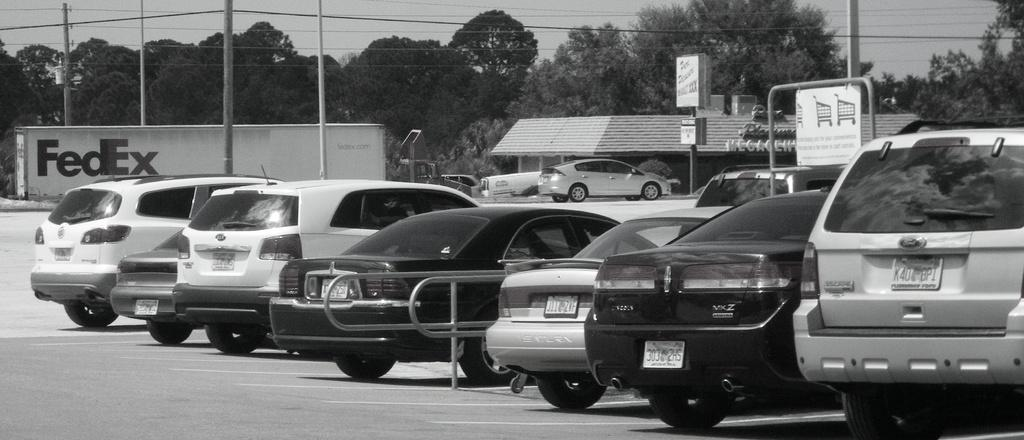What is the color scheme of the image? The image is black and white. What types of vehicles can be seen in the image? There are vehicles in the image. What kind of establishment is present in the image? There is a store in the image. What structures are visible in the image? There are poles in the image. What type of signage is present in the image? There are boards in the image. What type of vegetation is present in the image? There are plants and trees in the image. What part of the natural environment is visible in the image? The sky is visible in the image. What other objects can be seen in the image? There are objects in the image. Can you see a boy attempting to climb a twig in the image? There is no boy or twig present in the image. 